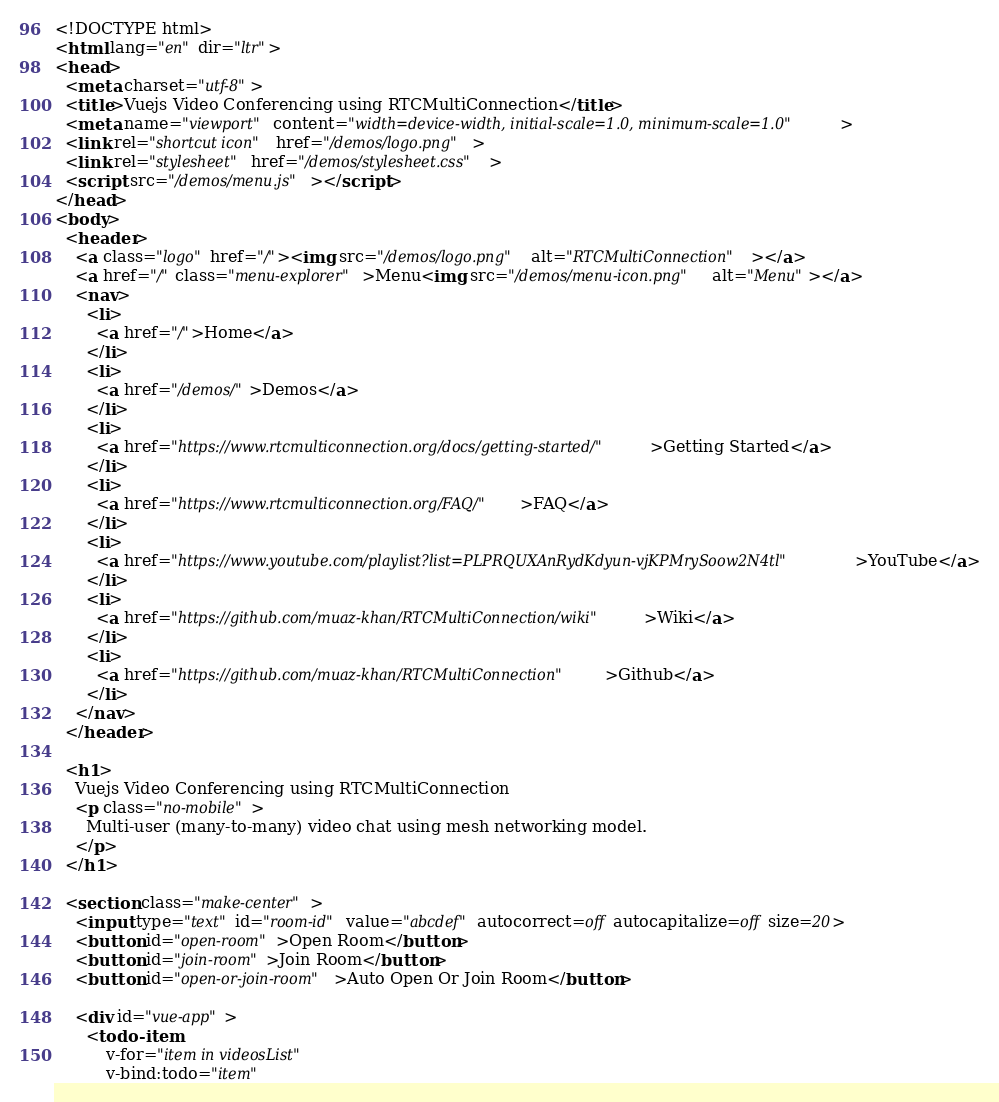Convert code to text. <code><loc_0><loc_0><loc_500><loc_500><_HTML_><!DOCTYPE html>
<html lang="en" dir="ltr">
<head>
  <meta charset="utf-8">
  <title>Vuejs Video Conferencing using RTCMultiConnection</title>
  <meta name="viewport" content="width=device-width, initial-scale=1.0, minimum-scale=1.0">
  <link rel="shortcut icon" href="/demos/logo.png">
  <link rel="stylesheet" href="/demos/stylesheet.css">
  <script src="/demos/menu.js"></script>
</head>
<body>
  <header>
    <a class="logo" href="/"><img src="/demos/logo.png" alt="RTCMultiConnection"></a>
    <a href="/" class="menu-explorer">Menu<img src="/demos/menu-icon.png" alt="Menu"></a>
    <nav>
      <li>
        <a href="/">Home</a>
      </li>
      <li>
        <a href="/demos/">Demos</a>
      </li>
      <li>
        <a href="https://www.rtcmulticonnection.org/docs/getting-started/">Getting Started</a>
      </li>
      <li>
        <a href="https://www.rtcmulticonnection.org/FAQ/">FAQ</a>
      </li>
      <li>
        <a href="https://www.youtube.com/playlist?list=PLPRQUXAnRydKdyun-vjKPMrySoow2N4tl">YouTube</a>
      </li>
      <li>
        <a href="https://github.com/muaz-khan/RTCMultiConnection/wiki">Wiki</a>
      </li>
      <li>
        <a href="https://github.com/muaz-khan/RTCMultiConnection">Github</a>
      </li>
    </nav>
  </header>

  <h1>
    Vuejs Video Conferencing using RTCMultiConnection
    <p class="no-mobile">
      Multi-user (many-to-many) video chat using mesh networking model.
    </p>
  </h1>

  <section class="make-center">
    <input type="text" id="room-id" value="abcdef" autocorrect=off autocapitalize=off size=20>
    <button id="open-room">Open Room</button>
    <button id="join-room">Join Room</button>
    <button id="open-or-join-room">Auto Open Or Join Room</button>

    <div id="vue-app">
      <todo-item
          v-for="item in videosList"
          v-bind:todo="item"</code> 